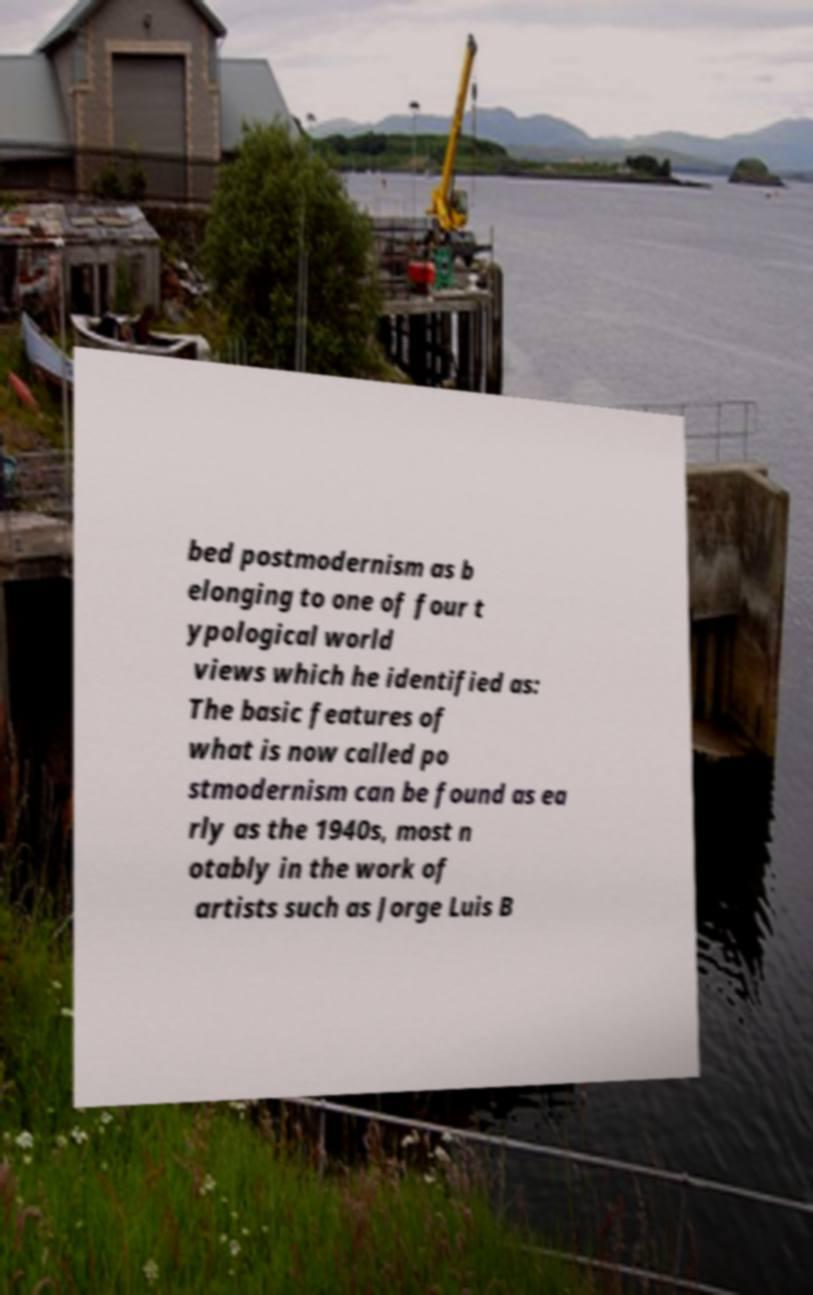Could you assist in decoding the text presented in this image and type it out clearly? bed postmodernism as b elonging to one of four t ypological world views which he identified as: The basic features of what is now called po stmodernism can be found as ea rly as the 1940s, most n otably in the work of artists such as Jorge Luis B 